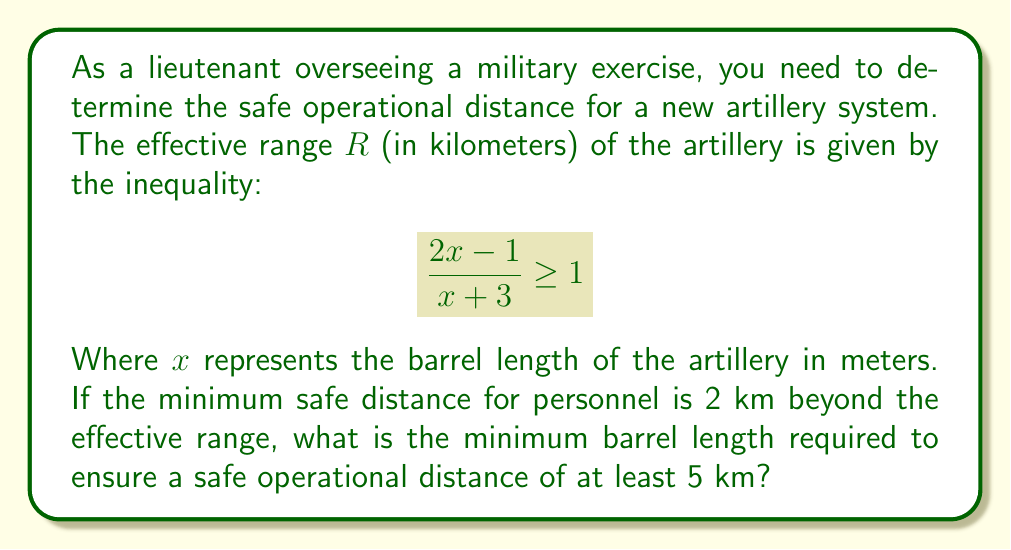Show me your answer to this math problem. Let's solve this step-by-step:

1) First, we need to solve the inequality for x:

   $$\frac{2x-1}{x+3} \geq 1$$

2) Multiply both sides by $(x+3)$:
   
   $$(2x-1) \geq (x+3)$$

3) Expand the right side:
   
   $$2x-1 \geq x+3$$

4) Subtract $x$ from both sides:
   
   $$x-1 \geq 3$$

5) Add 1 to both sides:
   
   $$x \geq 4$$

6) So, the effective range $R$ is given when the barrel length $x \geq 4$ meters.

7) Now, we need to find the barrel length for a safe operational distance of 5 km.
   Given: Safe distance = Effective range + 2 km
   
   $$5 = R + 2$$
   $$R = 3$$

8) Substitute this back into the original inequality:

   $$\frac{2x-1}{x+3} = 3$$

9) Solve this equation:
   
   $$2x-1 = 3(x+3)$$
   $$2x-1 = 3x+9$$
   $$-1 = x+9$$
   $$-10 = x$$

10) However, we know from step 5 that $x \geq 4$. Therefore, the minimum barrel length is 4 meters.
Answer: 4 meters 